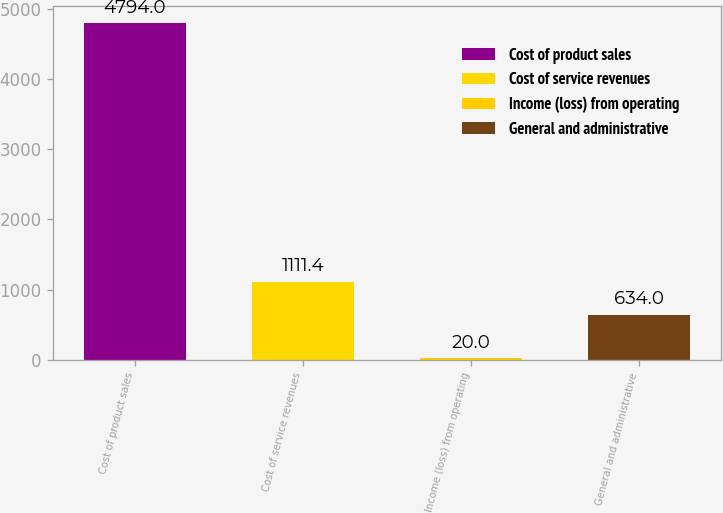Convert chart to OTSL. <chart><loc_0><loc_0><loc_500><loc_500><bar_chart><fcel>Cost of product sales<fcel>Cost of service revenues<fcel>Income (loss) from operating<fcel>General and administrative<nl><fcel>4794<fcel>1111.4<fcel>20<fcel>634<nl></chart> 